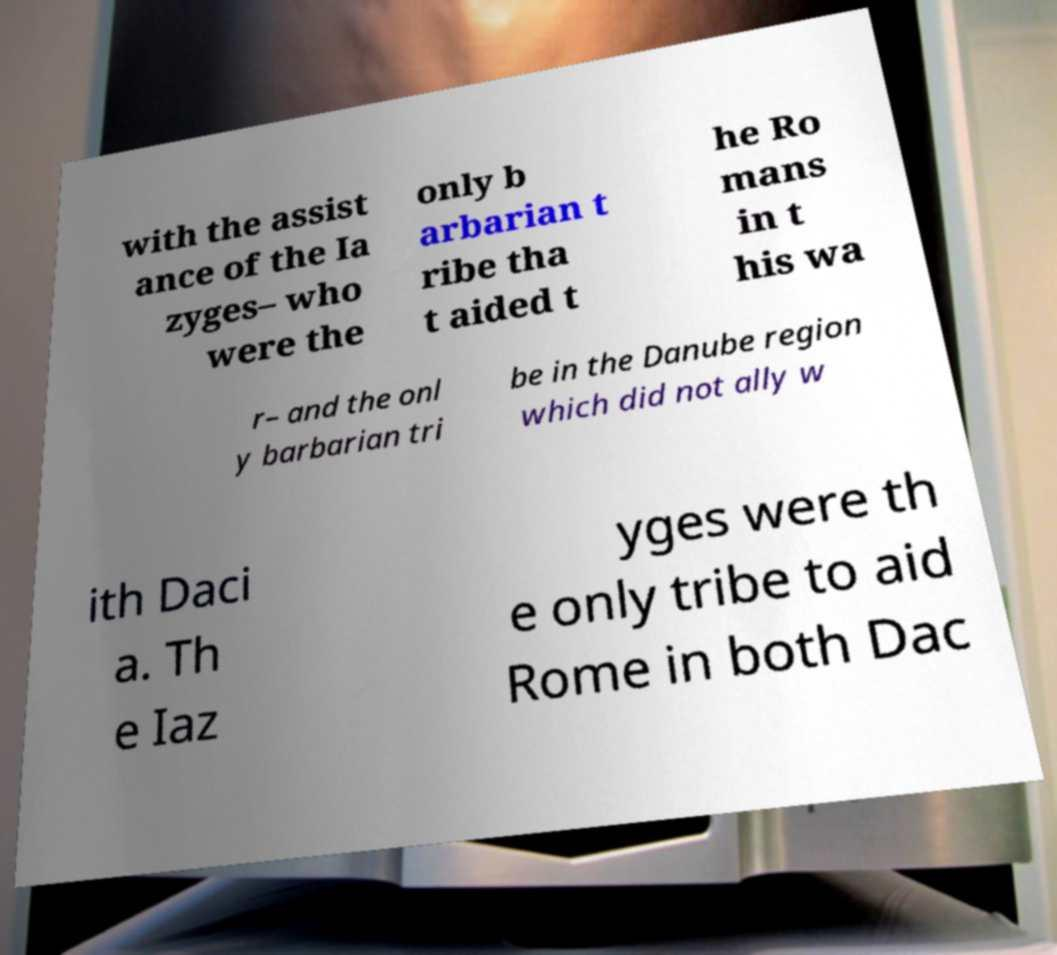What messages or text are displayed in this image? I need them in a readable, typed format. with the assist ance of the Ia zyges– who were the only b arbarian t ribe tha t aided t he Ro mans in t his wa r– and the onl y barbarian tri be in the Danube region which did not ally w ith Daci a. Th e Iaz yges were th e only tribe to aid Rome in both Dac 